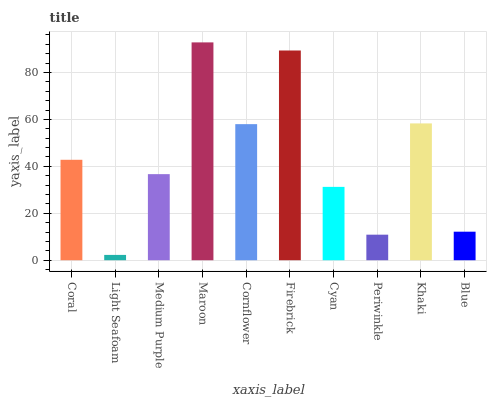Is Light Seafoam the minimum?
Answer yes or no. Yes. Is Maroon the maximum?
Answer yes or no. Yes. Is Medium Purple the minimum?
Answer yes or no. No. Is Medium Purple the maximum?
Answer yes or no. No. Is Medium Purple greater than Light Seafoam?
Answer yes or no. Yes. Is Light Seafoam less than Medium Purple?
Answer yes or no. Yes. Is Light Seafoam greater than Medium Purple?
Answer yes or no. No. Is Medium Purple less than Light Seafoam?
Answer yes or no. No. Is Coral the high median?
Answer yes or no. Yes. Is Medium Purple the low median?
Answer yes or no. Yes. Is Blue the high median?
Answer yes or no. No. Is Khaki the low median?
Answer yes or no. No. 